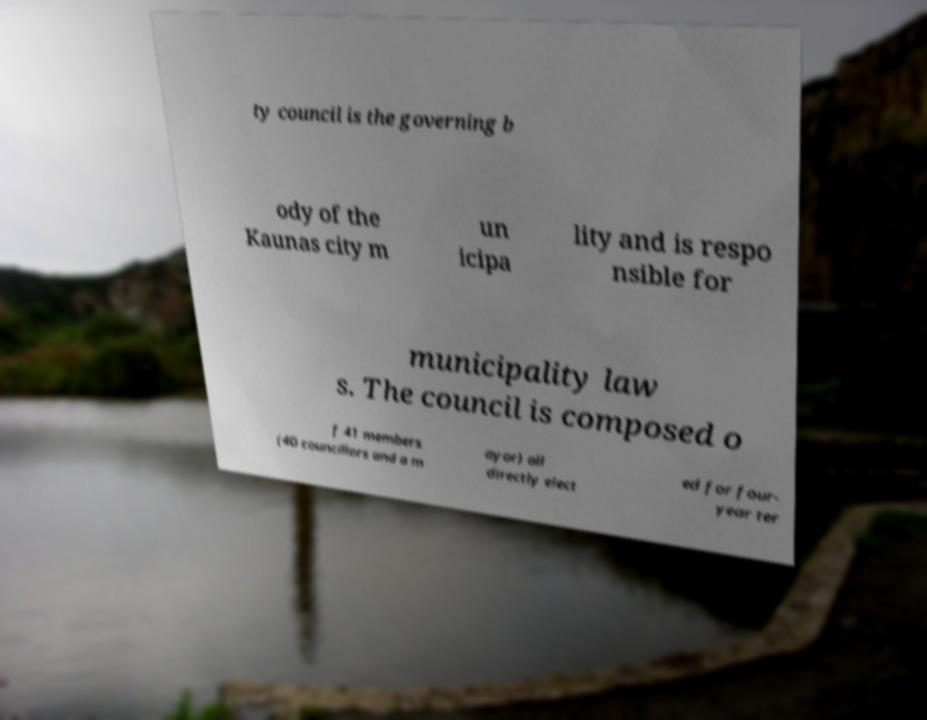Please identify and transcribe the text found in this image. ty council is the governing b ody of the Kaunas city m un icipa lity and is respo nsible for municipality law s. The council is composed o f 41 members (40 councillors and a m ayor) all directly elect ed for four- year ter 